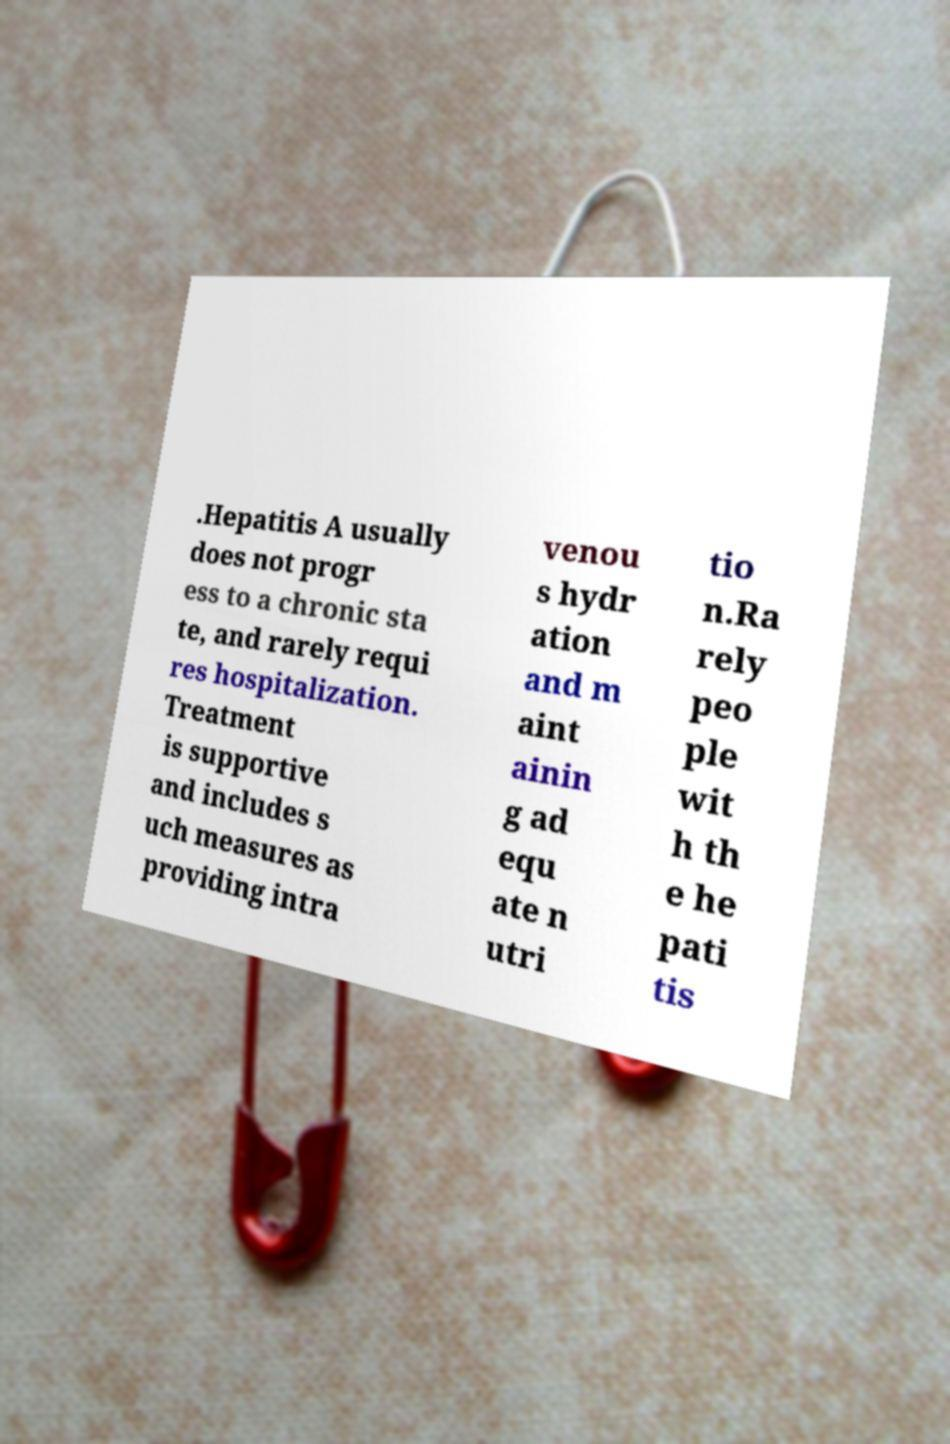What messages or text are displayed in this image? I need them in a readable, typed format. .Hepatitis A usually does not progr ess to a chronic sta te, and rarely requi res hospitalization. Treatment is supportive and includes s uch measures as providing intra venou s hydr ation and m aint ainin g ad equ ate n utri tio n.Ra rely peo ple wit h th e he pati tis 